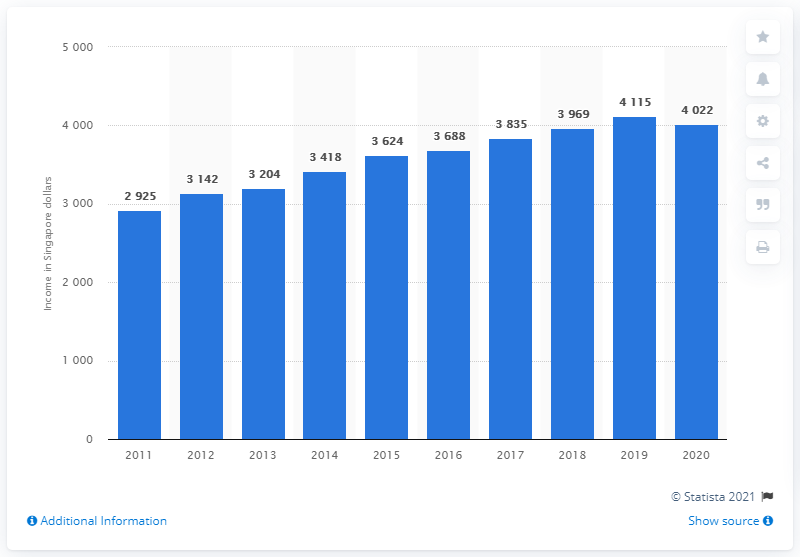Outline some significant characteristics in this image. In 2019, the average monthly household income was the highest among all years. The average monthly income is calculated by taking the sum of all monthly incomes and dividing it by the total number of incomes. In this example, the highest monthly income is 3520, and the lowest monthly income is also 3520. Therefore, the average monthly income can be calculated as (3520 + 3520) / 2 = 7040 / 2 = 3520. 